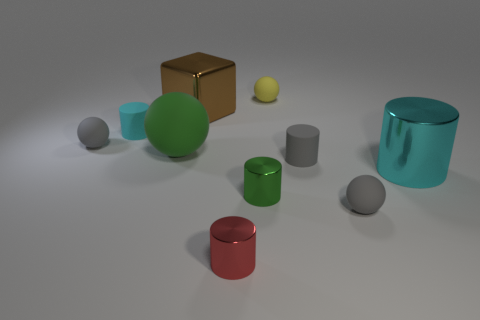Subtract 1 spheres. How many spheres are left? 3 Subtract all yellow balls. How many balls are left? 3 Subtract all tiny rubber cylinders. How many cylinders are left? 3 Subtract all purple balls. Subtract all blue blocks. How many balls are left? 4 Subtract all balls. How many objects are left? 6 Subtract all green cylinders. Subtract all gray balls. How many objects are left? 7 Add 7 tiny red cylinders. How many tiny red cylinders are left? 8 Add 3 yellow spheres. How many yellow spheres exist? 4 Subtract 0 yellow blocks. How many objects are left? 10 